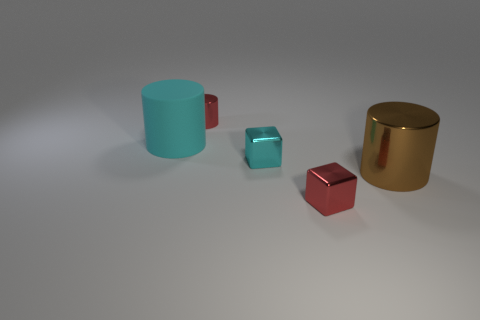What time of day or lighting situation does this scene represent? The scene seems to represent an indoor setting with soft, diffused lighting, perhaps from an overhead source, which doesn't suggest a specific time of day but rather a controlled interior environment. 